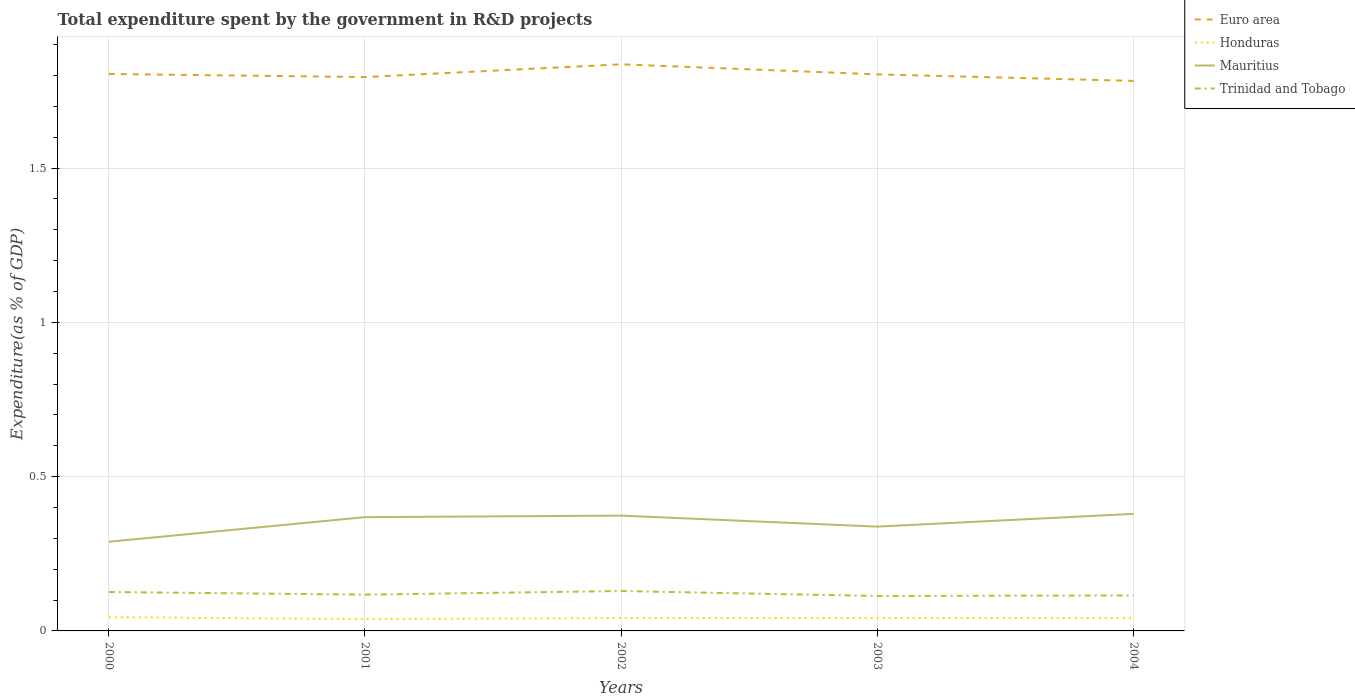How many different coloured lines are there?
Keep it short and to the point. 4. Does the line corresponding to Honduras intersect with the line corresponding to Mauritius?
Give a very brief answer. No. Across all years, what is the maximum total expenditure spent by the government in R&D projects in Mauritius?
Your answer should be very brief. 0.29. In which year was the total expenditure spent by the government in R&D projects in Mauritius maximum?
Give a very brief answer. 2000. What is the total total expenditure spent by the government in R&D projects in Mauritius in the graph?
Keep it short and to the point. -0.08. What is the difference between the highest and the second highest total expenditure spent by the government in R&D projects in Mauritius?
Provide a succinct answer. 0.09. Is the total expenditure spent by the government in R&D projects in Trinidad and Tobago strictly greater than the total expenditure spent by the government in R&D projects in Mauritius over the years?
Keep it short and to the point. Yes. How many lines are there?
Provide a short and direct response. 4. What is the difference between two consecutive major ticks on the Y-axis?
Your response must be concise. 0.5. Does the graph contain any zero values?
Offer a very short reply. No. Where does the legend appear in the graph?
Your answer should be very brief. Top right. How many legend labels are there?
Your response must be concise. 4. What is the title of the graph?
Offer a very short reply. Total expenditure spent by the government in R&D projects. What is the label or title of the Y-axis?
Give a very brief answer. Expenditure(as % of GDP). What is the Expenditure(as % of GDP) in Euro area in 2000?
Your answer should be very brief. 1.81. What is the Expenditure(as % of GDP) in Honduras in 2000?
Offer a very short reply. 0.04. What is the Expenditure(as % of GDP) in Mauritius in 2000?
Provide a short and direct response. 0.29. What is the Expenditure(as % of GDP) of Trinidad and Tobago in 2000?
Keep it short and to the point. 0.13. What is the Expenditure(as % of GDP) of Euro area in 2001?
Your answer should be very brief. 1.8. What is the Expenditure(as % of GDP) of Honduras in 2001?
Keep it short and to the point. 0.04. What is the Expenditure(as % of GDP) of Mauritius in 2001?
Give a very brief answer. 0.37. What is the Expenditure(as % of GDP) in Trinidad and Tobago in 2001?
Give a very brief answer. 0.12. What is the Expenditure(as % of GDP) of Euro area in 2002?
Offer a very short reply. 1.84. What is the Expenditure(as % of GDP) of Honduras in 2002?
Your answer should be very brief. 0.04. What is the Expenditure(as % of GDP) in Mauritius in 2002?
Give a very brief answer. 0.37. What is the Expenditure(as % of GDP) of Trinidad and Tobago in 2002?
Ensure brevity in your answer.  0.13. What is the Expenditure(as % of GDP) of Euro area in 2003?
Ensure brevity in your answer.  1.8. What is the Expenditure(as % of GDP) of Honduras in 2003?
Provide a succinct answer. 0.04. What is the Expenditure(as % of GDP) of Mauritius in 2003?
Make the answer very short. 0.34. What is the Expenditure(as % of GDP) of Trinidad and Tobago in 2003?
Make the answer very short. 0.11. What is the Expenditure(as % of GDP) in Euro area in 2004?
Give a very brief answer. 1.78. What is the Expenditure(as % of GDP) of Honduras in 2004?
Give a very brief answer. 0.04. What is the Expenditure(as % of GDP) of Mauritius in 2004?
Offer a very short reply. 0.38. What is the Expenditure(as % of GDP) of Trinidad and Tobago in 2004?
Your answer should be very brief. 0.11. Across all years, what is the maximum Expenditure(as % of GDP) of Euro area?
Your answer should be compact. 1.84. Across all years, what is the maximum Expenditure(as % of GDP) of Honduras?
Give a very brief answer. 0.04. Across all years, what is the maximum Expenditure(as % of GDP) in Mauritius?
Make the answer very short. 0.38. Across all years, what is the maximum Expenditure(as % of GDP) in Trinidad and Tobago?
Ensure brevity in your answer.  0.13. Across all years, what is the minimum Expenditure(as % of GDP) of Euro area?
Your answer should be very brief. 1.78. Across all years, what is the minimum Expenditure(as % of GDP) of Honduras?
Keep it short and to the point. 0.04. Across all years, what is the minimum Expenditure(as % of GDP) in Mauritius?
Your response must be concise. 0.29. Across all years, what is the minimum Expenditure(as % of GDP) in Trinidad and Tobago?
Offer a very short reply. 0.11. What is the total Expenditure(as % of GDP) in Euro area in the graph?
Offer a terse response. 9.02. What is the total Expenditure(as % of GDP) of Honduras in the graph?
Offer a terse response. 0.21. What is the total Expenditure(as % of GDP) of Mauritius in the graph?
Provide a short and direct response. 1.75. What is the total Expenditure(as % of GDP) of Trinidad and Tobago in the graph?
Make the answer very short. 0.6. What is the difference between the Expenditure(as % of GDP) of Euro area in 2000 and that in 2001?
Your answer should be compact. 0.01. What is the difference between the Expenditure(as % of GDP) of Honduras in 2000 and that in 2001?
Keep it short and to the point. 0.01. What is the difference between the Expenditure(as % of GDP) of Mauritius in 2000 and that in 2001?
Give a very brief answer. -0.08. What is the difference between the Expenditure(as % of GDP) in Trinidad and Tobago in 2000 and that in 2001?
Provide a succinct answer. 0.01. What is the difference between the Expenditure(as % of GDP) of Euro area in 2000 and that in 2002?
Ensure brevity in your answer.  -0.03. What is the difference between the Expenditure(as % of GDP) in Honduras in 2000 and that in 2002?
Offer a terse response. 0. What is the difference between the Expenditure(as % of GDP) of Mauritius in 2000 and that in 2002?
Provide a short and direct response. -0.08. What is the difference between the Expenditure(as % of GDP) in Trinidad and Tobago in 2000 and that in 2002?
Offer a very short reply. -0. What is the difference between the Expenditure(as % of GDP) in Euro area in 2000 and that in 2003?
Ensure brevity in your answer.  0. What is the difference between the Expenditure(as % of GDP) in Honduras in 2000 and that in 2003?
Your answer should be very brief. 0. What is the difference between the Expenditure(as % of GDP) in Mauritius in 2000 and that in 2003?
Offer a terse response. -0.05. What is the difference between the Expenditure(as % of GDP) of Trinidad and Tobago in 2000 and that in 2003?
Your answer should be compact. 0.01. What is the difference between the Expenditure(as % of GDP) in Euro area in 2000 and that in 2004?
Give a very brief answer. 0.02. What is the difference between the Expenditure(as % of GDP) in Honduras in 2000 and that in 2004?
Your answer should be very brief. 0. What is the difference between the Expenditure(as % of GDP) in Mauritius in 2000 and that in 2004?
Give a very brief answer. -0.09. What is the difference between the Expenditure(as % of GDP) in Trinidad and Tobago in 2000 and that in 2004?
Your answer should be very brief. 0.01. What is the difference between the Expenditure(as % of GDP) of Euro area in 2001 and that in 2002?
Provide a short and direct response. -0.04. What is the difference between the Expenditure(as % of GDP) in Honduras in 2001 and that in 2002?
Give a very brief answer. -0. What is the difference between the Expenditure(as % of GDP) in Mauritius in 2001 and that in 2002?
Offer a terse response. -0.01. What is the difference between the Expenditure(as % of GDP) of Trinidad and Tobago in 2001 and that in 2002?
Provide a succinct answer. -0.01. What is the difference between the Expenditure(as % of GDP) of Euro area in 2001 and that in 2003?
Offer a terse response. -0.01. What is the difference between the Expenditure(as % of GDP) of Honduras in 2001 and that in 2003?
Offer a terse response. -0. What is the difference between the Expenditure(as % of GDP) of Mauritius in 2001 and that in 2003?
Your answer should be compact. 0.03. What is the difference between the Expenditure(as % of GDP) in Trinidad and Tobago in 2001 and that in 2003?
Make the answer very short. 0. What is the difference between the Expenditure(as % of GDP) in Euro area in 2001 and that in 2004?
Provide a succinct answer. 0.01. What is the difference between the Expenditure(as % of GDP) of Honduras in 2001 and that in 2004?
Offer a very short reply. -0. What is the difference between the Expenditure(as % of GDP) of Mauritius in 2001 and that in 2004?
Your answer should be compact. -0.01. What is the difference between the Expenditure(as % of GDP) of Trinidad and Tobago in 2001 and that in 2004?
Your answer should be compact. 0. What is the difference between the Expenditure(as % of GDP) of Euro area in 2002 and that in 2003?
Provide a succinct answer. 0.03. What is the difference between the Expenditure(as % of GDP) in Honduras in 2002 and that in 2003?
Your response must be concise. -0. What is the difference between the Expenditure(as % of GDP) in Mauritius in 2002 and that in 2003?
Your answer should be compact. 0.04. What is the difference between the Expenditure(as % of GDP) in Trinidad and Tobago in 2002 and that in 2003?
Give a very brief answer. 0.02. What is the difference between the Expenditure(as % of GDP) in Euro area in 2002 and that in 2004?
Your response must be concise. 0.05. What is the difference between the Expenditure(as % of GDP) in Mauritius in 2002 and that in 2004?
Provide a succinct answer. -0.01. What is the difference between the Expenditure(as % of GDP) of Trinidad and Tobago in 2002 and that in 2004?
Provide a succinct answer. 0.01. What is the difference between the Expenditure(as % of GDP) in Euro area in 2003 and that in 2004?
Provide a succinct answer. 0.02. What is the difference between the Expenditure(as % of GDP) in Honduras in 2003 and that in 2004?
Offer a terse response. 0. What is the difference between the Expenditure(as % of GDP) in Mauritius in 2003 and that in 2004?
Your answer should be compact. -0.04. What is the difference between the Expenditure(as % of GDP) in Trinidad and Tobago in 2003 and that in 2004?
Give a very brief answer. -0. What is the difference between the Expenditure(as % of GDP) of Euro area in 2000 and the Expenditure(as % of GDP) of Honduras in 2001?
Your answer should be very brief. 1.77. What is the difference between the Expenditure(as % of GDP) in Euro area in 2000 and the Expenditure(as % of GDP) in Mauritius in 2001?
Offer a terse response. 1.44. What is the difference between the Expenditure(as % of GDP) of Euro area in 2000 and the Expenditure(as % of GDP) of Trinidad and Tobago in 2001?
Your answer should be very brief. 1.69. What is the difference between the Expenditure(as % of GDP) in Honduras in 2000 and the Expenditure(as % of GDP) in Mauritius in 2001?
Provide a succinct answer. -0.32. What is the difference between the Expenditure(as % of GDP) of Honduras in 2000 and the Expenditure(as % of GDP) of Trinidad and Tobago in 2001?
Offer a terse response. -0.07. What is the difference between the Expenditure(as % of GDP) of Mauritius in 2000 and the Expenditure(as % of GDP) of Trinidad and Tobago in 2001?
Offer a very short reply. 0.17. What is the difference between the Expenditure(as % of GDP) of Euro area in 2000 and the Expenditure(as % of GDP) of Honduras in 2002?
Make the answer very short. 1.76. What is the difference between the Expenditure(as % of GDP) in Euro area in 2000 and the Expenditure(as % of GDP) in Mauritius in 2002?
Provide a short and direct response. 1.43. What is the difference between the Expenditure(as % of GDP) of Euro area in 2000 and the Expenditure(as % of GDP) of Trinidad and Tobago in 2002?
Your answer should be compact. 1.68. What is the difference between the Expenditure(as % of GDP) in Honduras in 2000 and the Expenditure(as % of GDP) in Mauritius in 2002?
Your response must be concise. -0.33. What is the difference between the Expenditure(as % of GDP) in Honduras in 2000 and the Expenditure(as % of GDP) in Trinidad and Tobago in 2002?
Ensure brevity in your answer.  -0.08. What is the difference between the Expenditure(as % of GDP) in Mauritius in 2000 and the Expenditure(as % of GDP) in Trinidad and Tobago in 2002?
Offer a very short reply. 0.16. What is the difference between the Expenditure(as % of GDP) in Euro area in 2000 and the Expenditure(as % of GDP) in Honduras in 2003?
Ensure brevity in your answer.  1.76. What is the difference between the Expenditure(as % of GDP) of Euro area in 2000 and the Expenditure(as % of GDP) of Mauritius in 2003?
Provide a succinct answer. 1.47. What is the difference between the Expenditure(as % of GDP) of Euro area in 2000 and the Expenditure(as % of GDP) of Trinidad and Tobago in 2003?
Offer a terse response. 1.69. What is the difference between the Expenditure(as % of GDP) of Honduras in 2000 and the Expenditure(as % of GDP) of Mauritius in 2003?
Offer a terse response. -0.29. What is the difference between the Expenditure(as % of GDP) of Honduras in 2000 and the Expenditure(as % of GDP) of Trinidad and Tobago in 2003?
Your answer should be very brief. -0.07. What is the difference between the Expenditure(as % of GDP) in Mauritius in 2000 and the Expenditure(as % of GDP) in Trinidad and Tobago in 2003?
Your response must be concise. 0.18. What is the difference between the Expenditure(as % of GDP) in Euro area in 2000 and the Expenditure(as % of GDP) in Honduras in 2004?
Offer a terse response. 1.76. What is the difference between the Expenditure(as % of GDP) in Euro area in 2000 and the Expenditure(as % of GDP) in Mauritius in 2004?
Ensure brevity in your answer.  1.43. What is the difference between the Expenditure(as % of GDP) in Euro area in 2000 and the Expenditure(as % of GDP) in Trinidad and Tobago in 2004?
Provide a short and direct response. 1.69. What is the difference between the Expenditure(as % of GDP) in Honduras in 2000 and the Expenditure(as % of GDP) in Mauritius in 2004?
Keep it short and to the point. -0.33. What is the difference between the Expenditure(as % of GDP) in Honduras in 2000 and the Expenditure(as % of GDP) in Trinidad and Tobago in 2004?
Your response must be concise. -0.07. What is the difference between the Expenditure(as % of GDP) of Mauritius in 2000 and the Expenditure(as % of GDP) of Trinidad and Tobago in 2004?
Give a very brief answer. 0.17. What is the difference between the Expenditure(as % of GDP) of Euro area in 2001 and the Expenditure(as % of GDP) of Honduras in 2002?
Your answer should be very brief. 1.75. What is the difference between the Expenditure(as % of GDP) in Euro area in 2001 and the Expenditure(as % of GDP) in Mauritius in 2002?
Offer a terse response. 1.42. What is the difference between the Expenditure(as % of GDP) in Euro area in 2001 and the Expenditure(as % of GDP) in Trinidad and Tobago in 2002?
Keep it short and to the point. 1.67. What is the difference between the Expenditure(as % of GDP) of Honduras in 2001 and the Expenditure(as % of GDP) of Mauritius in 2002?
Your answer should be very brief. -0.34. What is the difference between the Expenditure(as % of GDP) of Honduras in 2001 and the Expenditure(as % of GDP) of Trinidad and Tobago in 2002?
Ensure brevity in your answer.  -0.09. What is the difference between the Expenditure(as % of GDP) of Mauritius in 2001 and the Expenditure(as % of GDP) of Trinidad and Tobago in 2002?
Make the answer very short. 0.24. What is the difference between the Expenditure(as % of GDP) of Euro area in 2001 and the Expenditure(as % of GDP) of Honduras in 2003?
Ensure brevity in your answer.  1.75. What is the difference between the Expenditure(as % of GDP) of Euro area in 2001 and the Expenditure(as % of GDP) of Mauritius in 2003?
Your answer should be compact. 1.46. What is the difference between the Expenditure(as % of GDP) of Euro area in 2001 and the Expenditure(as % of GDP) of Trinidad and Tobago in 2003?
Provide a succinct answer. 1.68. What is the difference between the Expenditure(as % of GDP) of Honduras in 2001 and the Expenditure(as % of GDP) of Mauritius in 2003?
Provide a succinct answer. -0.3. What is the difference between the Expenditure(as % of GDP) of Honduras in 2001 and the Expenditure(as % of GDP) of Trinidad and Tobago in 2003?
Keep it short and to the point. -0.07. What is the difference between the Expenditure(as % of GDP) in Mauritius in 2001 and the Expenditure(as % of GDP) in Trinidad and Tobago in 2003?
Offer a terse response. 0.26. What is the difference between the Expenditure(as % of GDP) of Euro area in 2001 and the Expenditure(as % of GDP) of Honduras in 2004?
Your response must be concise. 1.75. What is the difference between the Expenditure(as % of GDP) in Euro area in 2001 and the Expenditure(as % of GDP) in Mauritius in 2004?
Your response must be concise. 1.42. What is the difference between the Expenditure(as % of GDP) in Euro area in 2001 and the Expenditure(as % of GDP) in Trinidad and Tobago in 2004?
Your answer should be compact. 1.68. What is the difference between the Expenditure(as % of GDP) in Honduras in 2001 and the Expenditure(as % of GDP) in Mauritius in 2004?
Provide a succinct answer. -0.34. What is the difference between the Expenditure(as % of GDP) in Honduras in 2001 and the Expenditure(as % of GDP) in Trinidad and Tobago in 2004?
Provide a short and direct response. -0.08. What is the difference between the Expenditure(as % of GDP) in Mauritius in 2001 and the Expenditure(as % of GDP) in Trinidad and Tobago in 2004?
Your answer should be compact. 0.25. What is the difference between the Expenditure(as % of GDP) in Euro area in 2002 and the Expenditure(as % of GDP) in Honduras in 2003?
Offer a terse response. 1.79. What is the difference between the Expenditure(as % of GDP) in Euro area in 2002 and the Expenditure(as % of GDP) in Mauritius in 2003?
Keep it short and to the point. 1.5. What is the difference between the Expenditure(as % of GDP) in Euro area in 2002 and the Expenditure(as % of GDP) in Trinidad and Tobago in 2003?
Give a very brief answer. 1.72. What is the difference between the Expenditure(as % of GDP) of Honduras in 2002 and the Expenditure(as % of GDP) of Mauritius in 2003?
Keep it short and to the point. -0.3. What is the difference between the Expenditure(as % of GDP) in Honduras in 2002 and the Expenditure(as % of GDP) in Trinidad and Tobago in 2003?
Provide a short and direct response. -0.07. What is the difference between the Expenditure(as % of GDP) in Mauritius in 2002 and the Expenditure(as % of GDP) in Trinidad and Tobago in 2003?
Offer a very short reply. 0.26. What is the difference between the Expenditure(as % of GDP) of Euro area in 2002 and the Expenditure(as % of GDP) of Honduras in 2004?
Your answer should be very brief. 1.79. What is the difference between the Expenditure(as % of GDP) in Euro area in 2002 and the Expenditure(as % of GDP) in Mauritius in 2004?
Your response must be concise. 1.46. What is the difference between the Expenditure(as % of GDP) in Euro area in 2002 and the Expenditure(as % of GDP) in Trinidad and Tobago in 2004?
Your answer should be very brief. 1.72. What is the difference between the Expenditure(as % of GDP) of Honduras in 2002 and the Expenditure(as % of GDP) of Mauritius in 2004?
Your answer should be compact. -0.34. What is the difference between the Expenditure(as % of GDP) of Honduras in 2002 and the Expenditure(as % of GDP) of Trinidad and Tobago in 2004?
Offer a terse response. -0.07. What is the difference between the Expenditure(as % of GDP) in Mauritius in 2002 and the Expenditure(as % of GDP) in Trinidad and Tobago in 2004?
Ensure brevity in your answer.  0.26. What is the difference between the Expenditure(as % of GDP) in Euro area in 2003 and the Expenditure(as % of GDP) in Honduras in 2004?
Ensure brevity in your answer.  1.76. What is the difference between the Expenditure(as % of GDP) in Euro area in 2003 and the Expenditure(as % of GDP) in Mauritius in 2004?
Ensure brevity in your answer.  1.42. What is the difference between the Expenditure(as % of GDP) of Euro area in 2003 and the Expenditure(as % of GDP) of Trinidad and Tobago in 2004?
Offer a terse response. 1.69. What is the difference between the Expenditure(as % of GDP) of Honduras in 2003 and the Expenditure(as % of GDP) of Mauritius in 2004?
Give a very brief answer. -0.34. What is the difference between the Expenditure(as % of GDP) in Honduras in 2003 and the Expenditure(as % of GDP) in Trinidad and Tobago in 2004?
Offer a very short reply. -0.07. What is the difference between the Expenditure(as % of GDP) in Mauritius in 2003 and the Expenditure(as % of GDP) in Trinidad and Tobago in 2004?
Offer a very short reply. 0.22. What is the average Expenditure(as % of GDP) of Euro area per year?
Ensure brevity in your answer.  1.8. What is the average Expenditure(as % of GDP) of Honduras per year?
Offer a terse response. 0.04. What is the average Expenditure(as % of GDP) of Mauritius per year?
Give a very brief answer. 0.35. What is the average Expenditure(as % of GDP) in Trinidad and Tobago per year?
Your answer should be very brief. 0.12. In the year 2000, what is the difference between the Expenditure(as % of GDP) in Euro area and Expenditure(as % of GDP) in Honduras?
Provide a short and direct response. 1.76. In the year 2000, what is the difference between the Expenditure(as % of GDP) in Euro area and Expenditure(as % of GDP) in Mauritius?
Provide a short and direct response. 1.52. In the year 2000, what is the difference between the Expenditure(as % of GDP) in Euro area and Expenditure(as % of GDP) in Trinidad and Tobago?
Your answer should be compact. 1.68. In the year 2000, what is the difference between the Expenditure(as % of GDP) of Honduras and Expenditure(as % of GDP) of Mauritius?
Provide a short and direct response. -0.24. In the year 2000, what is the difference between the Expenditure(as % of GDP) of Honduras and Expenditure(as % of GDP) of Trinidad and Tobago?
Your response must be concise. -0.08. In the year 2000, what is the difference between the Expenditure(as % of GDP) in Mauritius and Expenditure(as % of GDP) in Trinidad and Tobago?
Ensure brevity in your answer.  0.16. In the year 2001, what is the difference between the Expenditure(as % of GDP) in Euro area and Expenditure(as % of GDP) in Honduras?
Provide a short and direct response. 1.76. In the year 2001, what is the difference between the Expenditure(as % of GDP) in Euro area and Expenditure(as % of GDP) in Mauritius?
Provide a succinct answer. 1.43. In the year 2001, what is the difference between the Expenditure(as % of GDP) of Euro area and Expenditure(as % of GDP) of Trinidad and Tobago?
Your answer should be compact. 1.68. In the year 2001, what is the difference between the Expenditure(as % of GDP) of Honduras and Expenditure(as % of GDP) of Mauritius?
Provide a short and direct response. -0.33. In the year 2001, what is the difference between the Expenditure(as % of GDP) in Honduras and Expenditure(as % of GDP) in Trinidad and Tobago?
Your answer should be very brief. -0.08. In the year 2001, what is the difference between the Expenditure(as % of GDP) in Mauritius and Expenditure(as % of GDP) in Trinidad and Tobago?
Your response must be concise. 0.25. In the year 2002, what is the difference between the Expenditure(as % of GDP) in Euro area and Expenditure(as % of GDP) in Honduras?
Your response must be concise. 1.79. In the year 2002, what is the difference between the Expenditure(as % of GDP) in Euro area and Expenditure(as % of GDP) in Mauritius?
Your response must be concise. 1.46. In the year 2002, what is the difference between the Expenditure(as % of GDP) of Euro area and Expenditure(as % of GDP) of Trinidad and Tobago?
Your answer should be very brief. 1.71. In the year 2002, what is the difference between the Expenditure(as % of GDP) of Honduras and Expenditure(as % of GDP) of Mauritius?
Provide a succinct answer. -0.33. In the year 2002, what is the difference between the Expenditure(as % of GDP) in Honduras and Expenditure(as % of GDP) in Trinidad and Tobago?
Make the answer very short. -0.09. In the year 2002, what is the difference between the Expenditure(as % of GDP) in Mauritius and Expenditure(as % of GDP) in Trinidad and Tobago?
Your answer should be very brief. 0.24. In the year 2003, what is the difference between the Expenditure(as % of GDP) of Euro area and Expenditure(as % of GDP) of Honduras?
Keep it short and to the point. 1.76. In the year 2003, what is the difference between the Expenditure(as % of GDP) of Euro area and Expenditure(as % of GDP) of Mauritius?
Provide a short and direct response. 1.47. In the year 2003, what is the difference between the Expenditure(as % of GDP) of Euro area and Expenditure(as % of GDP) of Trinidad and Tobago?
Provide a succinct answer. 1.69. In the year 2003, what is the difference between the Expenditure(as % of GDP) of Honduras and Expenditure(as % of GDP) of Mauritius?
Make the answer very short. -0.3. In the year 2003, what is the difference between the Expenditure(as % of GDP) in Honduras and Expenditure(as % of GDP) in Trinidad and Tobago?
Your answer should be very brief. -0.07. In the year 2003, what is the difference between the Expenditure(as % of GDP) in Mauritius and Expenditure(as % of GDP) in Trinidad and Tobago?
Your answer should be compact. 0.22. In the year 2004, what is the difference between the Expenditure(as % of GDP) of Euro area and Expenditure(as % of GDP) of Honduras?
Provide a short and direct response. 1.74. In the year 2004, what is the difference between the Expenditure(as % of GDP) in Euro area and Expenditure(as % of GDP) in Mauritius?
Give a very brief answer. 1.4. In the year 2004, what is the difference between the Expenditure(as % of GDP) of Euro area and Expenditure(as % of GDP) of Trinidad and Tobago?
Ensure brevity in your answer.  1.67. In the year 2004, what is the difference between the Expenditure(as % of GDP) in Honduras and Expenditure(as % of GDP) in Mauritius?
Offer a terse response. -0.34. In the year 2004, what is the difference between the Expenditure(as % of GDP) of Honduras and Expenditure(as % of GDP) of Trinidad and Tobago?
Offer a terse response. -0.07. In the year 2004, what is the difference between the Expenditure(as % of GDP) in Mauritius and Expenditure(as % of GDP) in Trinidad and Tobago?
Offer a very short reply. 0.26. What is the ratio of the Expenditure(as % of GDP) in Euro area in 2000 to that in 2001?
Your answer should be compact. 1.01. What is the ratio of the Expenditure(as % of GDP) of Honduras in 2000 to that in 2001?
Offer a very short reply. 1.16. What is the ratio of the Expenditure(as % of GDP) of Mauritius in 2000 to that in 2001?
Keep it short and to the point. 0.78. What is the ratio of the Expenditure(as % of GDP) of Trinidad and Tobago in 2000 to that in 2001?
Provide a short and direct response. 1.07. What is the ratio of the Expenditure(as % of GDP) in Euro area in 2000 to that in 2002?
Give a very brief answer. 0.98. What is the ratio of the Expenditure(as % of GDP) in Honduras in 2000 to that in 2002?
Offer a very short reply. 1.07. What is the ratio of the Expenditure(as % of GDP) in Mauritius in 2000 to that in 2002?
Offer a very short reply. 0.77. What is the ratio of the Expenditure(as % of GDP) in Trinidad and Tobago in 2000 to that in 2002?
Provide a short and direct response. 0.98. What is the ratio of the Expenditure(as % of GDP) in Honduras in 2000 to that in 2003?
Provide a succinct answer. 1.06. What is the ratio of the Expenditure(as % of GDP) in Mauritius in 2000 to that in 2003?
Give a very brief answer. 0.85. What is the ratio of the Expenditure(as % of GDP) in Trinidad and Tobago in 2000 to that in 2003?
Offer a very short reply. 1.11. What is the ratio of the Expenditure(as % of GDP) in Euro area in 2000 to that in 2004?
Give a very brief answer. 1.01. What is the ratio of the Expenditure(as % of GDP) of Honduras in 2000 to that in 2004?
Provide a short and direct response. 1.07. What is the ratio of the Expenditure(as % of GDP) in Mauritius in 2000 to that in 2004?
Provide a short and direct response. 0.76. What is the ratio of the Expenditure(as % of GDP) of Trinidad and Tobago in 2000 to that in 2004?
Give a very brief answer. 1.1. What is the ratio of the Expenditure(as % of GDP) of Euro area in 2001 to that in 2002?
Provide a short and direct response. 0.98. What is the ratio of the Expenditure(as % of GDP) of Honduras in 2001 to that in 2002?
Keep it short and to the point. 0.92. What is the ratio of the Expenditure(as % of GDP) of Mauritius in 2001 to that in 2002?
Ensure brevity in your answer.  0.99. What is the ratio of the Expenditure(as % of GDP) in Trinidad and Tobago in 2001 to that in 2002?
Your response must be concise. 0.91. What is the ratio of the Expenditure(as % of GDP) of Honduras in 2001 to that in 2003?
Make the answer very short. 0.91. What is the ratio of the Expenditure(as % of GDP) of Mauritius in 2001 to that in 2003?
Your answer should be very brief. 1.09. What is the ratio of the Expenditure(as % of GDP) in Trinidad and Tobago in 2001 to that in 2003?
Your answer should be very brief. 1.04. What is the ratio of the Expenditure(as % of GDP) of Euro area in 2001 to that in 2004?
Ensure brevity in your answer.  1.01. What is the ratio of the Expenditure(as % of GDP) of Honduras in 2001 to that in 2004?
Provide a short and direct response. 0.92. What is the ratio of the Expenditure(as % of GDP) in Mauritius in 2001 to that in 2004?
Offer a terse response. 0.97. What is the ratio of the Expenditure(as % of GDP) of Trinidad and Tobago in 2001 to that in 2004?
Keep it short and to the point. 1.02. What is the ratio of the Expenditure(as % of GDP) of Euro area in 2002 to that in 2003?
Your answer should be compact. 1.02. What is the ratio of the Expenditure(as % of GDP) of Mauritius in 2002 to that in 2003?
Give a very brief answer. 1.11. What is the ratio of the Expenditure(as % of GDP) of Trinidad and Tobago in 2002 to that in 2003?
Provide a short and direct response. 1.14. What is the ratio of the Expenditure(as % of GDP) of Euro area in 2002 to that in 2004?
Your answer should be compact. 1.03. What is the ratio of the Expenditure(as % of GDP) of Honduras in 2002 to that in 2004?
Keep it short and to the point. 1.01. What is the ratio of the Expenditure(as % of GDP) in Mauritius in 2002 to that in 2004?
Your response must be concise. 0.99. What is the ratio of the Expenditure(as % of GDP) in Trinidad and Tobago in 2002 to that in 2004?
Give a very brief answer. 1.12. What is the ratio of the Expenditure(as % of GDP) of Euro area in 2003 to that in 2004?
Provide a short and direct response. 1.01. What is the ratio of the Expenditure(as % of GDP) in Honduras in 2003 to that in 2004?
Your answer should be very brief. 1.01. What is the ratio of the Expenditure(as % of GDP) of Mauritius in 2003 to that in 2004?
Your answer should be very brief. 0.89. What is the ratio of the Expenditure(as % of GDP) in Trinidad and Tobago in 2003 to that in 2004?
Offer a terse response. 0.99. What is the difference between the highest and the second highest Expenditure(as % of GDP) of Euro area?
Make the answer very short. 0.03. What is the difference between the highest and the second highest Expenditure(as % of GDP) in Honduras?
Your response must be concise. 0. What is the difference between the highest and the second highest Expenditure(as % of GDP) in Mauritius?
Ensure brevity in your answer.  0.01. What is the difference between the highest and the second highest Expenditure(as % of GDP) of Trinidad and Tobago?
Ensure brevity in your answer.  0. What is the difference between the highest and the lowest Expenditure(as % of GDP) in Euro area?
Your response must be concise. 0.05. What is the difference between the highest and the lowest Expenditure(as % of GDP) of Honduras?
Ensure brevity in your answer.  0.01. What is the difference between the highest and the lowest Expenditure(as % of GDP) of Mauritius?
Your answer should be compact. 0.09. What is the difference between the highest and the lowest Expenditure(as % of GDP) of Trinidad and Tobago?
Ensure brevity in your answer.  0.02. 